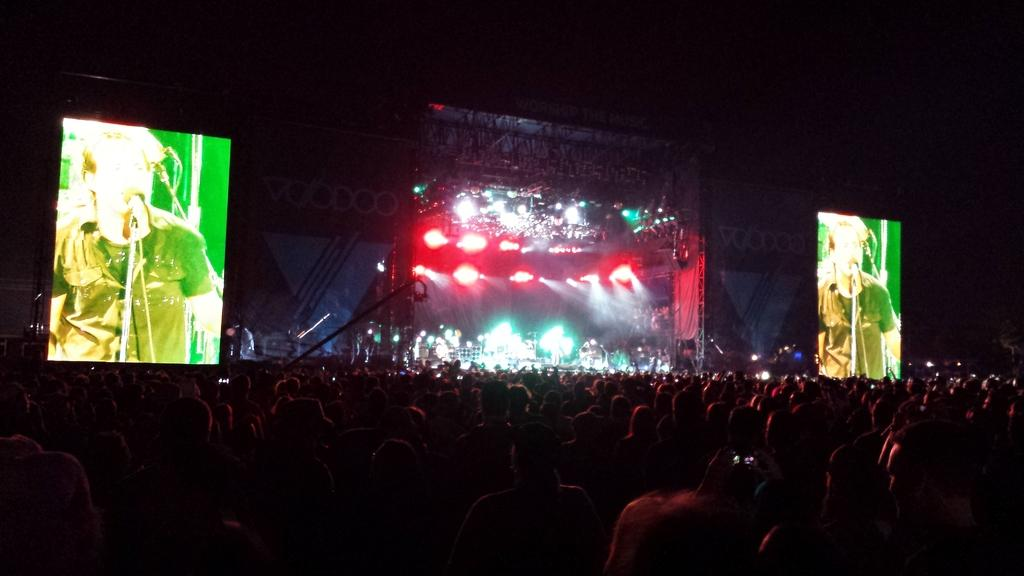What event is taking place in the image? There is a concert in the image. Where are the people located in the image? There is a crowd at the bottom of the image. What can be seen on the left side of the image? There is a screen on the left side of the image. What can be seen on the right side of the image? There is a screen on the right side of the image. Can you see a hill in the background of the image? There is no hill visible in the image. What type of cork is being used to hold the instruments in place during the concert? There is no cork present in the image, and no instruments are shown being held in place. 